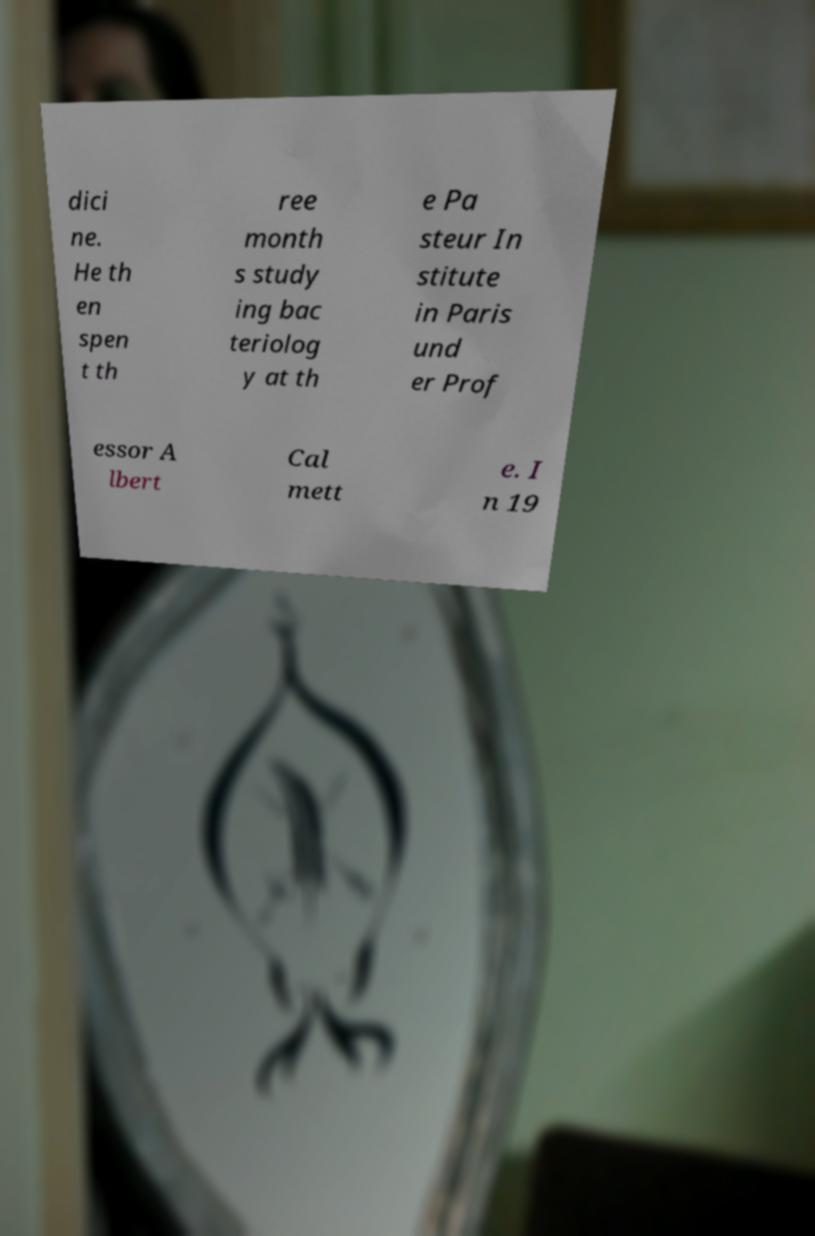Please read and relay the text visible in this image. What does it say? dici ne. He th en spen t th ree month s study ing bac teriolog y at th e Pa steur In stitute in Paris und er Prof essor A lbert Cal mett e. I n 19 